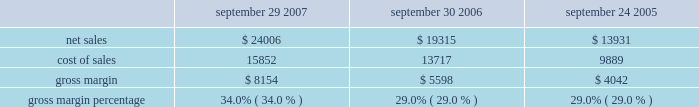Capital asset purchases associated with the retail segment were $ 294 million in 2007 , bringing the total capital asset purchases since inception of the retail segment to $ 1.0 billion .
As of september 29 , 2007 , the retail segment had approximately 7900 employees and had outstanding operating lease commitments associated with retail store space and related facilities of $ 1.1 billion .
The company would incur substantial costs if it were to close multiple retail stores .
Such costs could adversely affect the company 2019s financial condition and operating results .
Other segments the company 2019s other segments , which consists of its asia pacific and filemaker operations , experienced an increase in net sales of $ 406 million , or 30% ( 30 % ) during 2007 compared to 2006 .
This increase related primarily to a 58% ( 58 % ) increase in sales of mac portable products and strong ipod sales in the company 2019s asia pacific region .
During 2006 , net sales in other segments increased 35% ( 35 % ) compared to 2005 primarily due to an increase in sales of ipod and mac portable products .
Strong sales growth was a result of the introduction of the updated ipods featuring video-playing capabilities and the new intel-based mac portable products that translated to a 16% ( 16 % ) increase in mac unit sales during 2006 compared to 2005 .
Gross margin gross margin for each of the last three fiscal years are as follows ( in millions , except gross margin percentages ) : september 29 , september 30 , september 24 , 2007 2006 2005 .
Gross margin percentage of 34.0% ( 34.0 % ) in 2007 increased significantly from 29.0% ( 29.0 % ) in 2006 .
The primary drivers of this increase were more favorable costs on certain commodity components , including nand flash memory and dram memory , higher overall revenue that provided for more leverage on fixed production costs and a higher percentage of revenue from the company 2019s direct sales channels .
The company anticipates that its gross margin and the gross margins of the personal computer , consumer electronics and mobile communication industries will be subject to pressure due to price competition .
The company expects gross margin percentage to decline sequentially in the first quarter of 2008 primarily as a result of the full-quarter impact of product transitions and reduced pricing that were effected in the fourth quarter of 2007 , lower sales of ilife and iwork in their second quarter of availability , seasonally higher component costs , and a higher mix of indirect sales .
These factors are expected to be partially offset by higher sales of the company 2019s mac os x operating system due to the introduction of mac os x version 10.5 leopard ( 2018 2018mac os x leopard 2019 2019 ) that became available in october 2007 .
The foregoing statements regarding the company 2019s expected gross margin percentage are forward-looking .
There can be no assurance that current gross margin percentage will be maintained or targeted gross margin percentage levels will be achieved .
In general , gross margins and margins on individual products will remain under downward pressure due to a variety of factors , including continued industry wide global pricing pressures , increased competition , compressed product life cycles , potential increases in the cost and availability of raw material and outside manufacturing services , and a potential shift in the company 2019s sales mix towards products with lower gross margins .
In response to these competitive pressures , the company expects it will continue to take pricing actions with respect to its products .
Gross margins could also be affected by the company 2019s ability to effectively manage product quality and warranty costs and to stimulate .
What was the highest gross margin percentage for the three year period? 
Computations: table_max(gross margin percentage, none)
Answer: 0.34. 